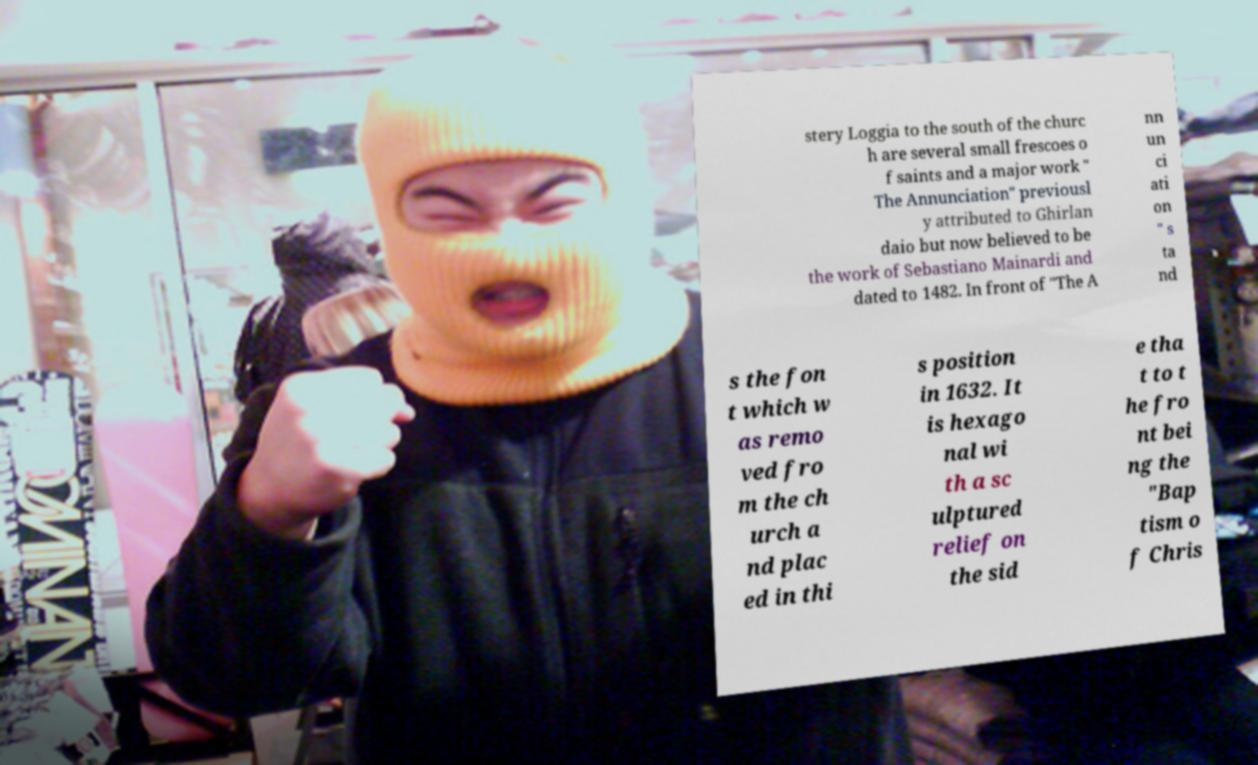Please read and relay the text visible in this image. What does it say? stery Loggia to the south of the churc h are several small frescoes o f saints and a major work " The Annunciation" previousl y attributed to Ghirlan daio but now believed to be the work of Sebastiano Mainardi and dated to 1482. In front of "The A nn un ci ati on " s ta nd s the fon t which w as remo ved fro m the ch urch a nd plac ed in thi s position in 1632. It is hexago nal wi th a sc ulptured relief on the sid e tha t to t he fro nt bei ng the "Bap tism o f Chris 